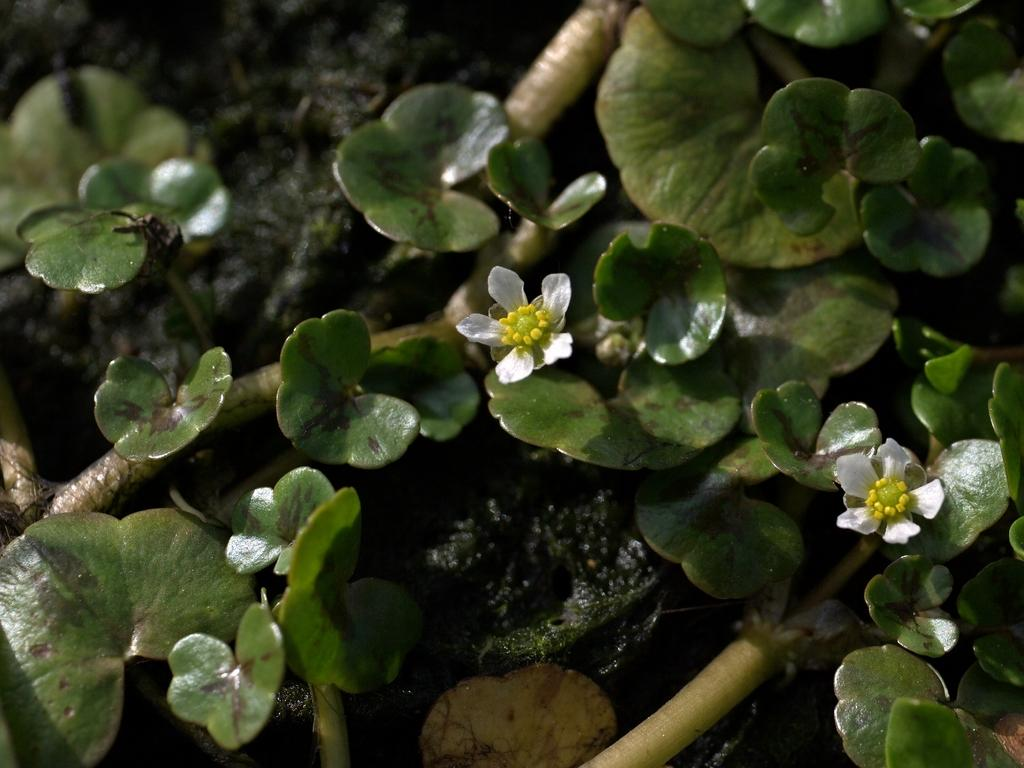What type of vegetation can be seen in the image? There are leaves in the image. What color are the flowers in the image? The flowers in the image are white. How does the wind affect the brush and jar in the image? There is no wind, brush, or jar present in the image. 